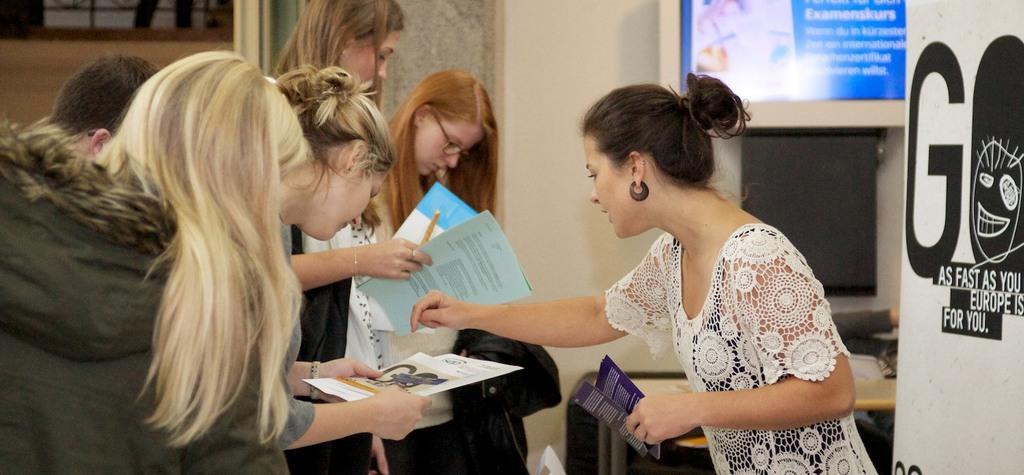Can you describe this image briefly? On the left side, there are persons in different color dresses. Some of them are holding documents. On the right side, there is a woman in white color T-shirt, holding brochures with a hand. Beside her, there is a banner. In the background, there is a poster attached to a wall, there are some objects arranged on a shelf and there are other objects. 